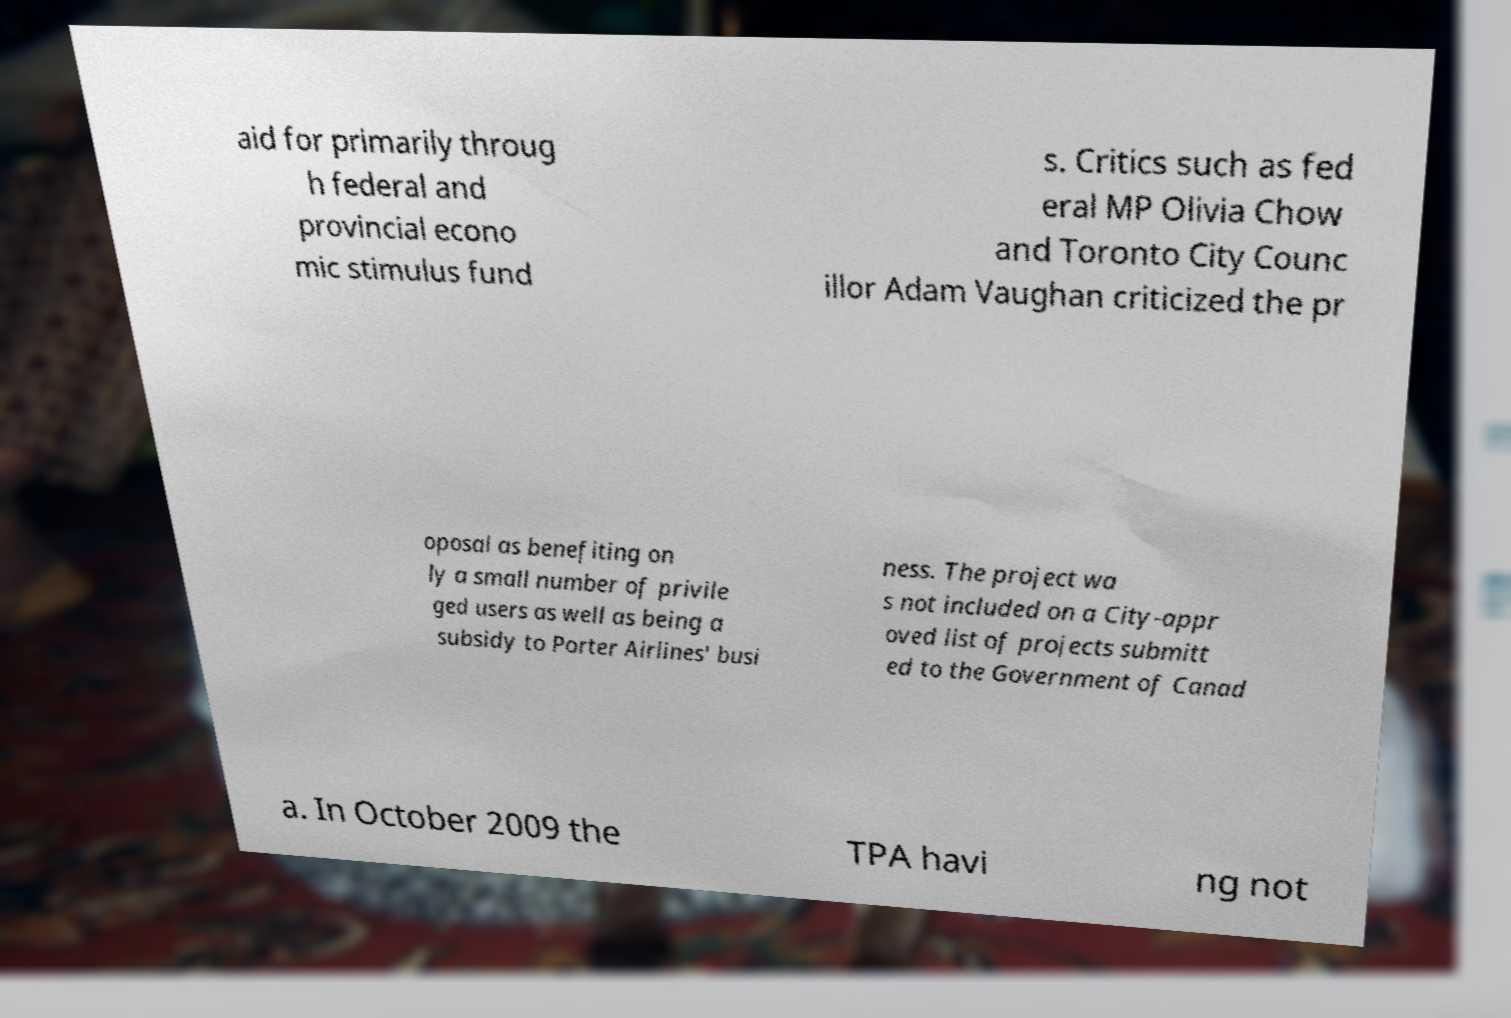Could you extract and type out the text from this image? aid for primarily throug h federal and provincial econo mic stimulus fund s. Critics such as fed eral MP Olivia Chow and Toronto City Counc illor Adam Vaughan criticized the pr oposal as benefiting on ly a small number of privile ged users as well as being a subsidy to Porter Airlines' busi ness. The project wa s not included on a City-appr oved list of projects submitt ed to the Government of Canad a. In October 2009 the TPA havi ng not 